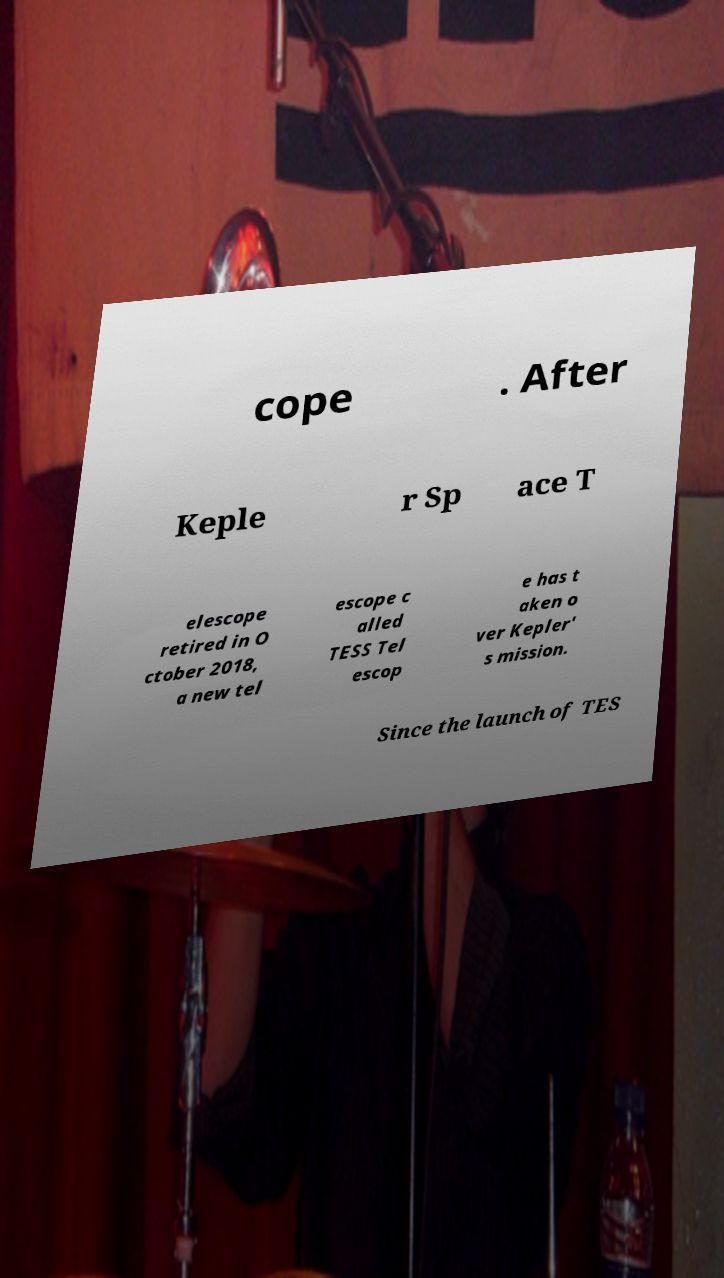I need the written content from this picture converted into text. Can you do that? cope . After Keple r Sp ace T elescope retired in O ctober 2018, a new tel escope c alled TESS Tel escop e has t aken o ver Kepler' s mission. Since the launch of TES 